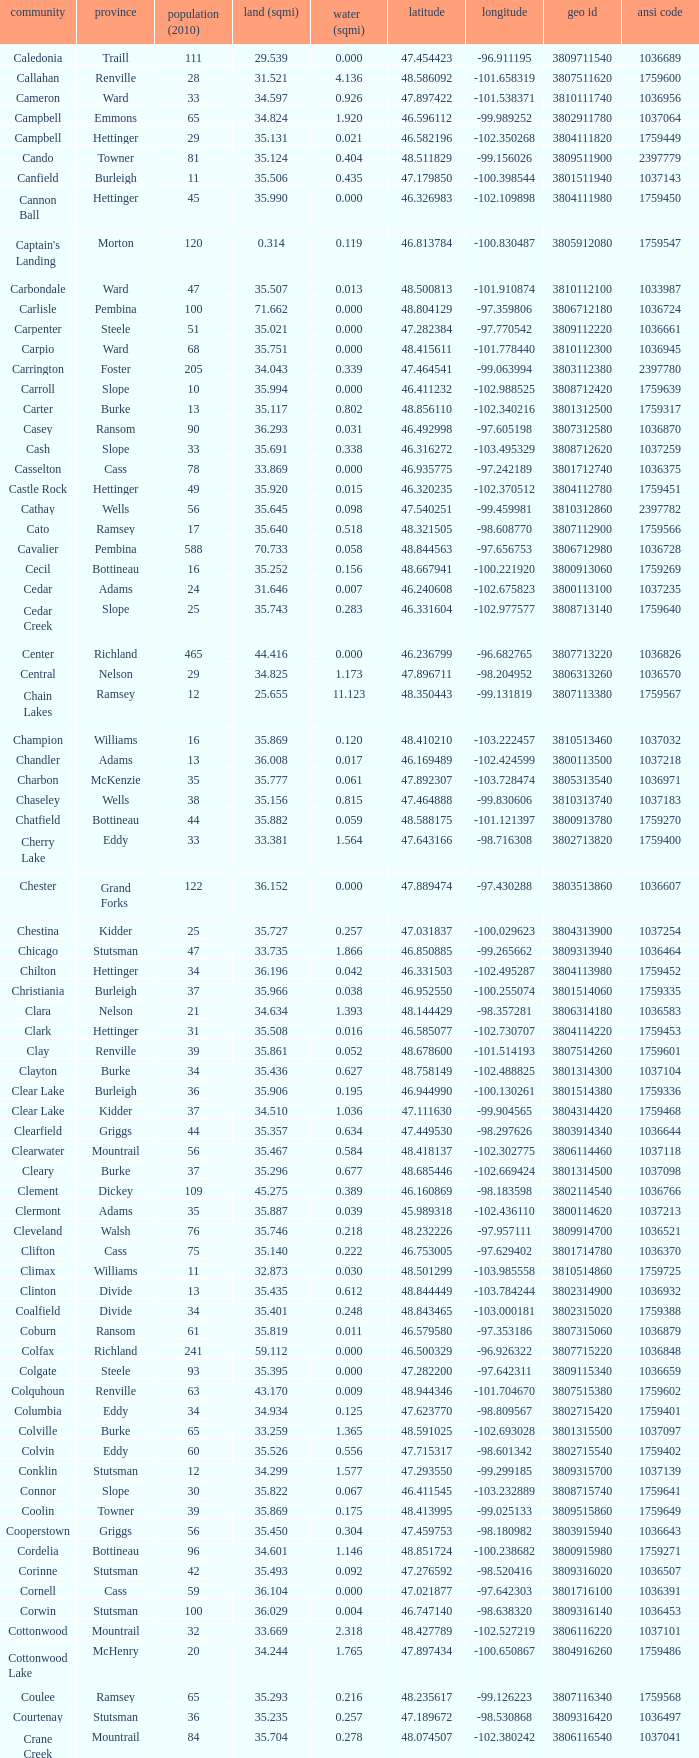What was the county with a longitude of -102.302775? Mountrail. 